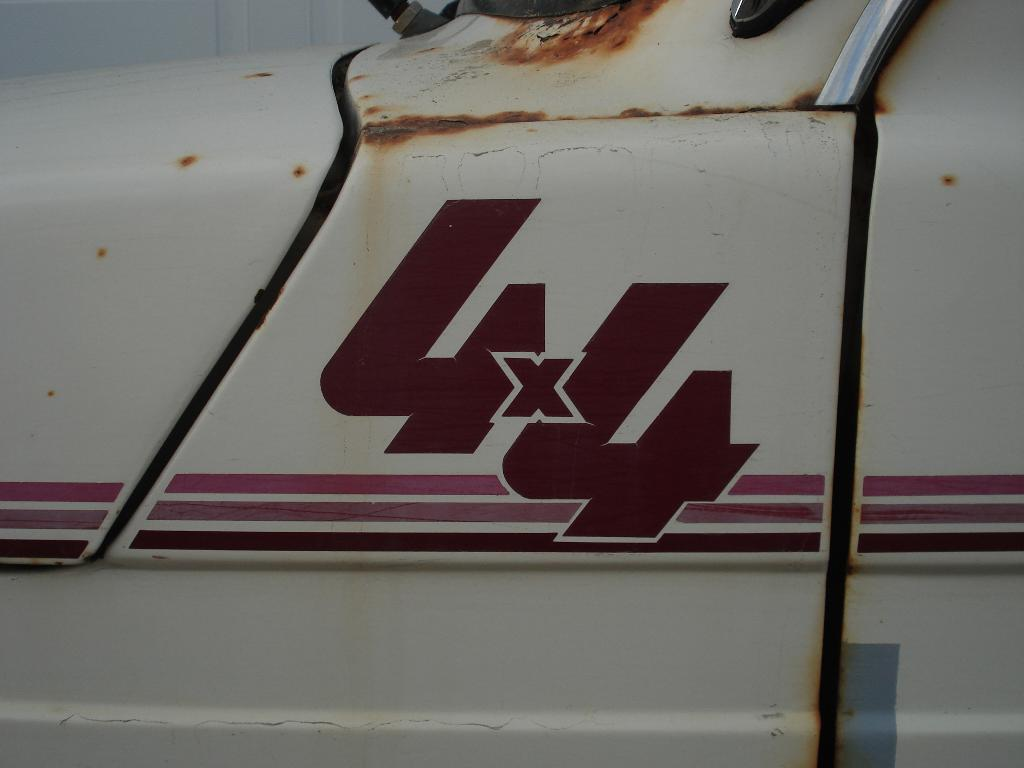What type of motor vehicle is in the image? The image contains a motor vehicle, but the specific type is not mentioned. Can you describe the motor vehicle's condition or appearance? The provided facts do not include any details about the motor vehicle's condition or appearance. Is the motor vehicle in motion or stationary in the image? The provided facts do not mention whether the motor vehicle is in motion or stationary. What is the name of the goat that is driving the motor vehicle in the image? There is no goat or any other animal driving the motor vehicle in the image. The motor vehicle is likely being driven by a human or is stationary. 